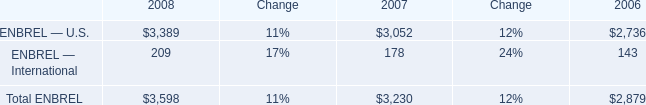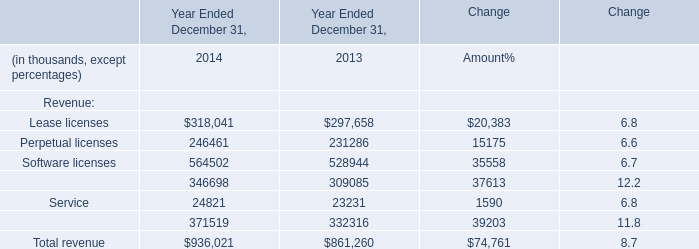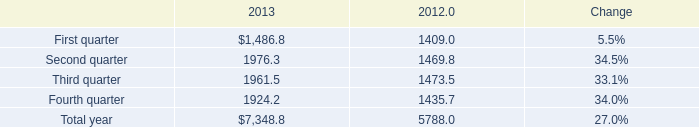What is the total amount of Third quarter of 2012, Perpetual licenses of Year Ended December 31, 2014, and First quarter of 2013 ? 
Computations: ((1473.5 + 246461.0) + 1486.8)
Answer: 249421.3. 